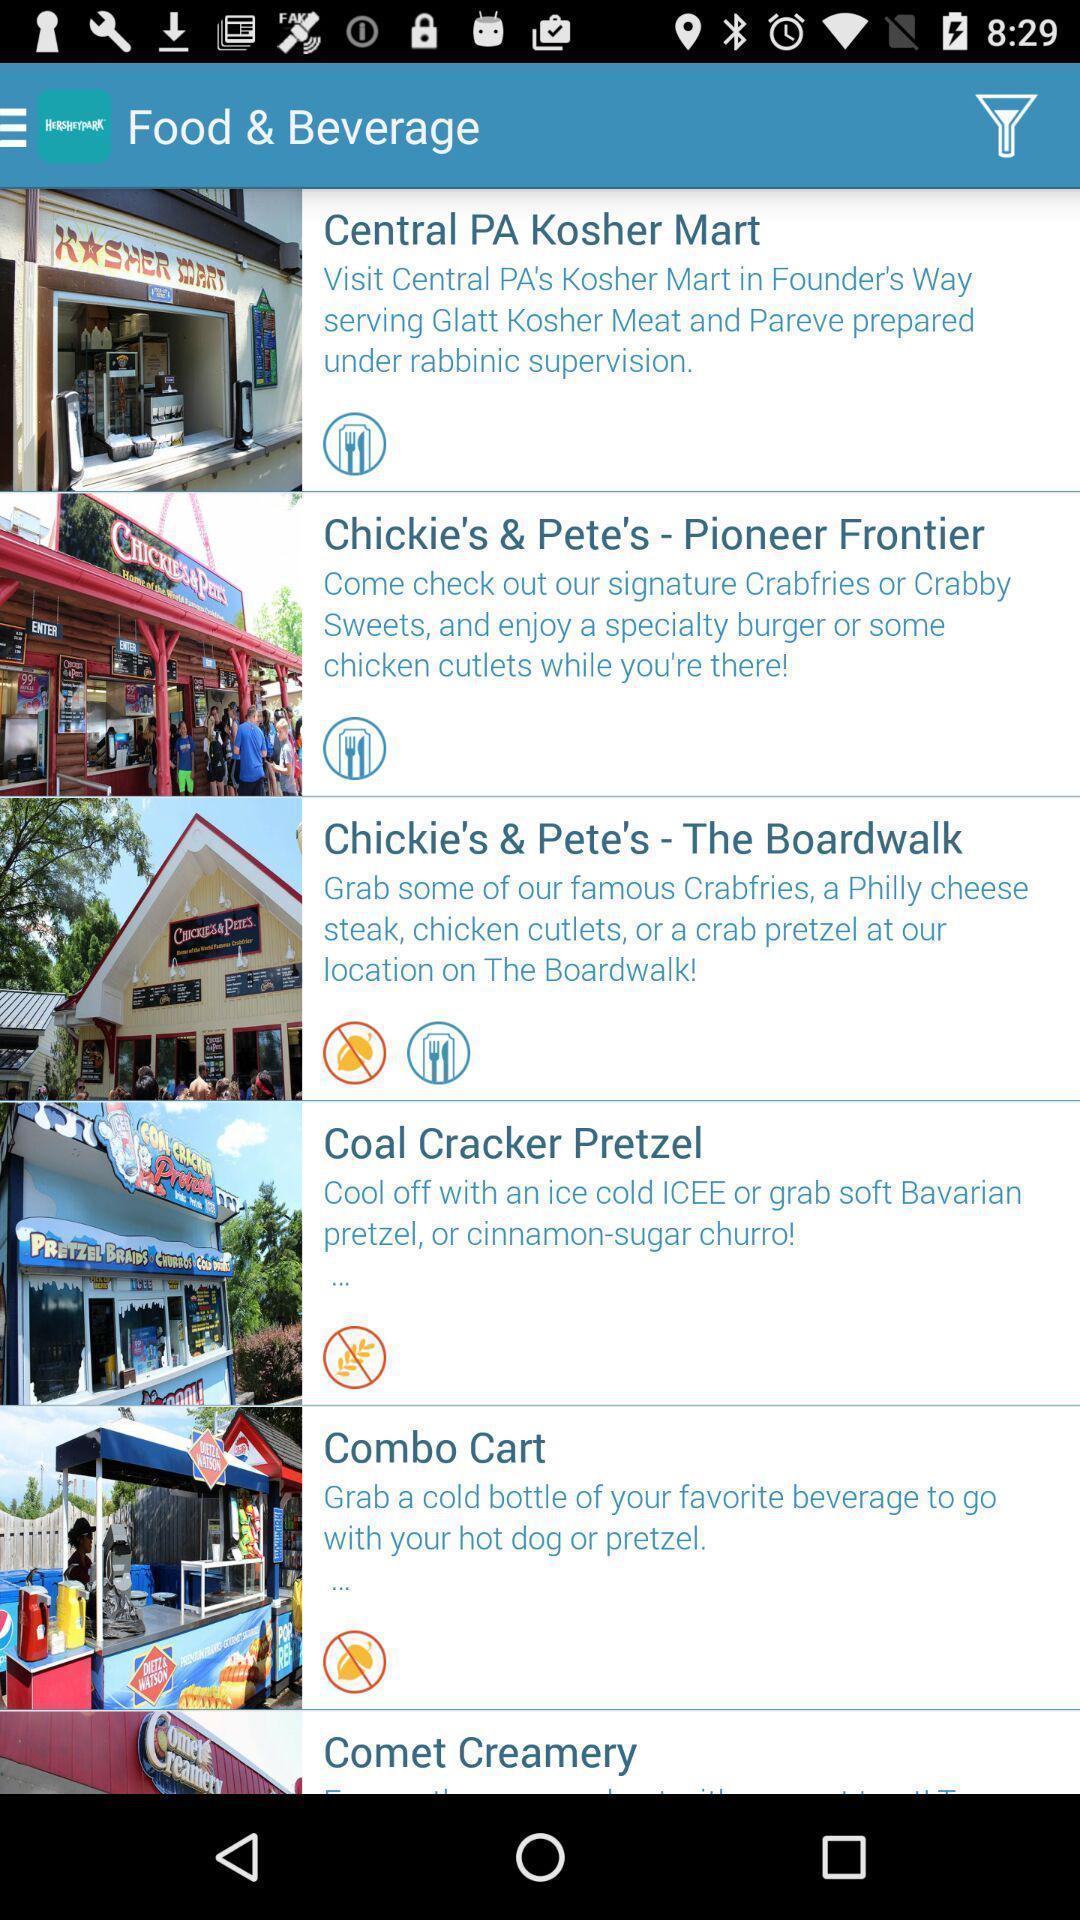Describe the key features of this screenshot. Screen showing food and beverage. 